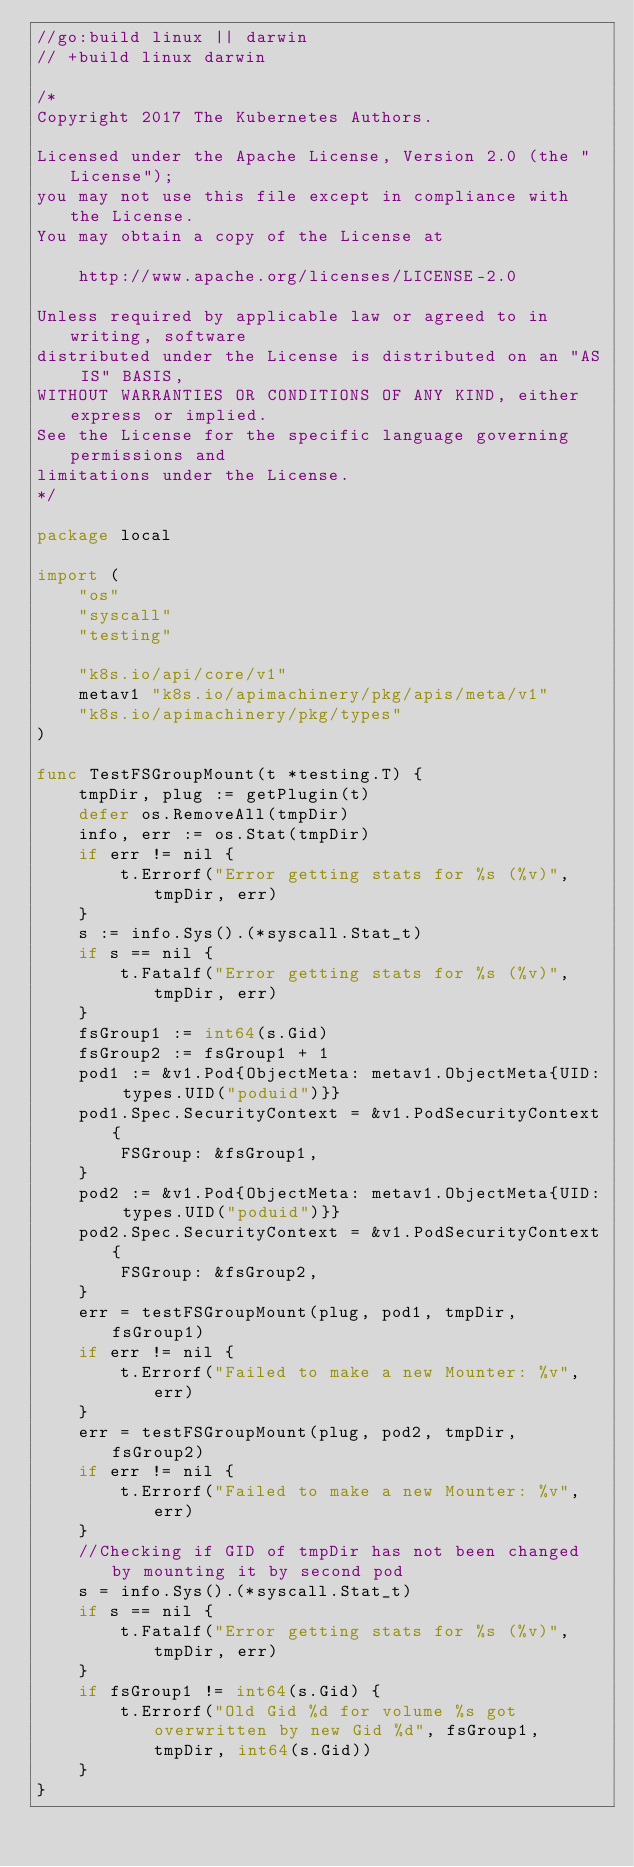<code> <loc_0><loc_0><loc_500><loc_500><_Go_>//go:build linux || darwin
// +build linux darwin

/*
Copyright 2017 The Kubernetes Authors.

Licensed under the Apache License, Version 2.0 (the "License");
you may not use this file except in compliance with the License.
You may obtain a copy of the License at

    http://www.apache.org/licenses/LICENSE-2.0

Unless required by applicable law or agreed to in writing, software
distributed under the License is distributed on an "AS IS" BASIS,
WITHOUT WARRANTIES OR CONDITIONS OF ANY KIND, either express or implied.
See the License for the specific language governing permissions and
limitations under the License.
*/

package local

import (
	"os"
	"syscall"
	"testing"

	"k8s.io/api/core/v1"
	metav1 "k8s.io/apimachinery/pkg/apis/meta/v1"
	"k8s.io/apimachinery/pkg/types"
)

func TestFSGroupMount(t *testing.T) {
	tmpDir, plug := getPlugin(t)
	defer os.RemoveAll(tmpDir)
	info, err := os.Stat(tmpDir)
	if err != nil {
		t.Errorf("Error getting stats for %s (%v)", tmpDir, err)
	}
	s := info.Sys().(*syscall.Stat_t)
	if s == nil {
		t.Fatalf("Error getting stats for %s (%v)", tmpDir, err)
	}
	fsGroup1 := int64(s.Gid)
	fsGroup2 := fsGroup1 + 1
	pod1 := &v1.Pod{ObjectMeta: metav1.ObjectMeta{UID: types.UID("poduid")}}
	pod1.Spec.SecurityContext = &v1.PodSecurityContext{
		FSGroup: &fsGroup1,
	}
	pod2 := &v1.Pod{ObjectMeta: metav1.ObjectMeta{UID: types.UID("poduid")}}
	pod2.Spec.SecurityContext = &v1.PodSecurityContext{
		FSGroup: &fsGroup2,
	}
	err = testFSGroupMount(plug, pod1, tmpDir, fsGroup1)
	if err != nil {
		t.Errorf("Failed to make a new Mounter: %v", err)
	}
	err = testFSGroupMount(plug, pod2, tmpDir, fsGroup2)
	if err != nil {
		t.Errorf("Failed to make a new Mounter: %v", err)
	}
	//Checking if GID of tmpDir has not been changed by mounting it by second pod
	s = info.Sys().(*syscall.Stat_t)
	if s == nil {
		t.Fatalf("Error getting stats for %s (%v)", tmpDir, err)
	}
	if fsGroup1 != int64(s.Gid) {
		t.Errorf("Old Gid %d for volume %s got overwritten by new Gid %d", fsGroup1, tmpDir, int64(s.Gid))
	}
}
</code> 